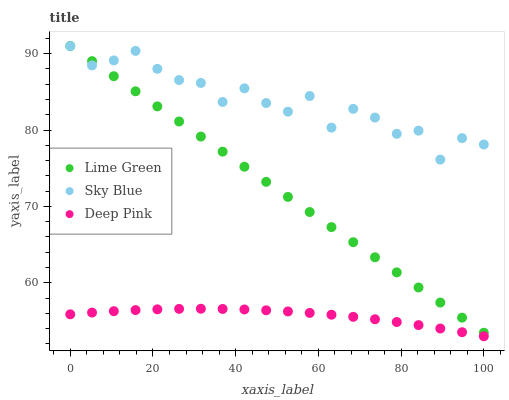Does Deep Pink have the minimum area under the curve?
Answer yes or no. Yes. Does Sky Blue have the maximum area under the curve?
Answer yes or no. Yes. Does Lime Green have the minimum area under the curve?
Answer yes or no. No. Does Lime Green have the maximum area under the curve?
Answer yes or no. No. Is Lime Green the smoothest?
Answer yes or no. Yes. Is Sky Blue the roughest?
Answer yes or no. Yes. Is Deep Pink the smoothest?
Answer yes or no. No. Is Deep Pink the roughest?
Answer yes or no. No. Does Deep Pink have the lowest value?
Answer yes or no. Yes. Does Lime Green have the lowest value?
Answer yes or no. No. Does Lime Green have the highest value?
Answer yes or no. Yes. Does Deep Pink have the highest value?
Answer yes or no. No. Is Deep Pink less than Sky Blue?
Answer yes or no. Yes. Is Sky Blue greater than Deep Pink?
Answer yes or no. Yes. Does Lime Green intersect Sky Blue?
Answer yes or no. Yes. Is Lime Green less than Sky Blue?
Answer yes or no. No. Is Lime Green greater than Sky Blue?
Answer yes or no. No. Does Deep Pink intersect Sky Blue?
Answer yes or no. No. 